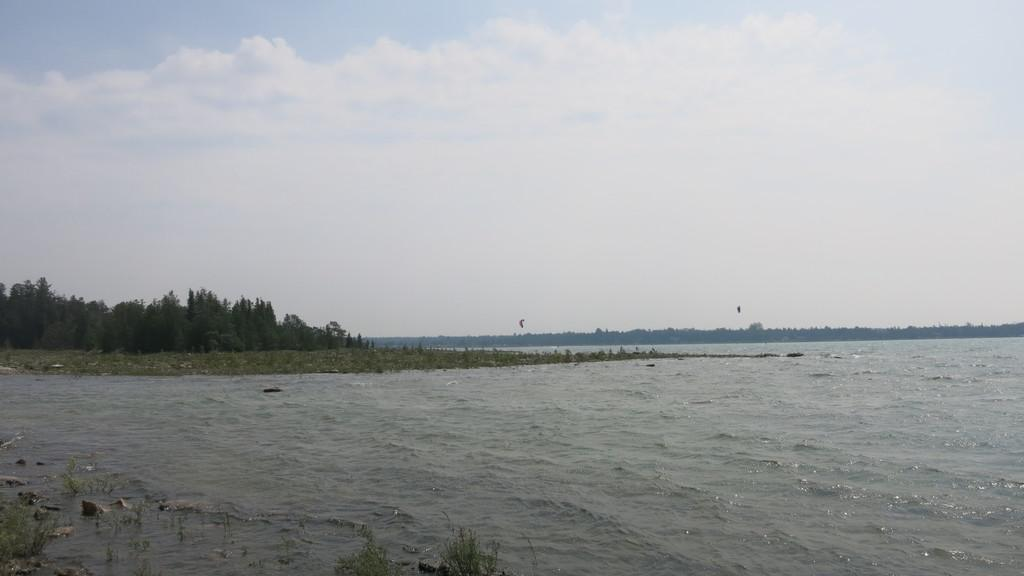What type of vegetation can be seen in the image? There are trees in the image. What natural element is visible in the image besides the trees? There is water visible in the image. What animals can be seen in the image? Birds are flying in the image. How would you describe the sky in the image? The sky is blue and cloudy. What type of paper is being used to care for the trees in the image? There is no paper or care for trees mentioned in the image; it features trees, water, birds, and a blue and cloudy sky. 